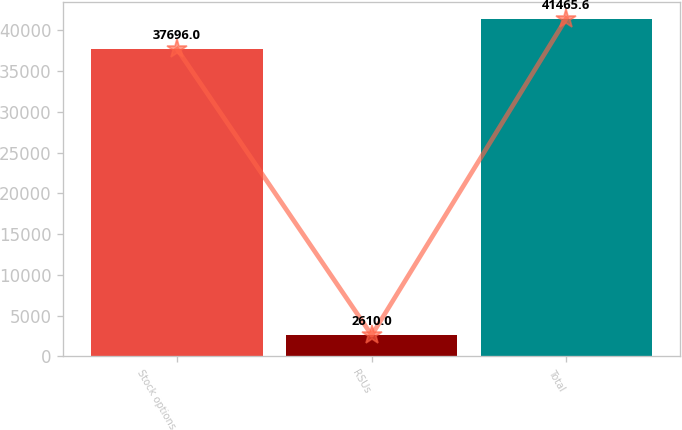Convert chart. <chart><loc_0><loc_0><loc_500><loc_500><bar_chart><fcel>Stock options<fcel>RSUs<fcel>Total<nl><fcel>37696<fcel>2610<fcel>41465.6<nl></chart> 